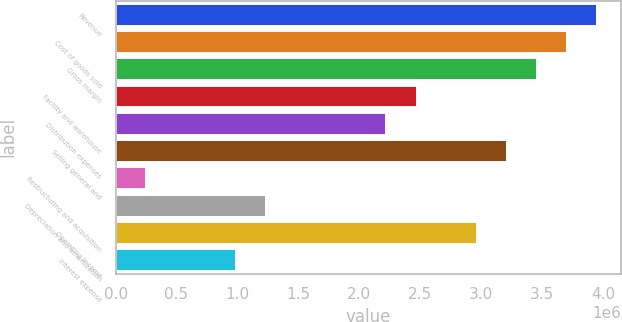Convert chart. <chart><loc_0><loc_0><loc_500><loc_500><bar_chart><fcel>Revenue<fcel>Cost of goods sold<fcel>Gross margin<fcel>Facility and warehouse<fcel>Distribution expenses<fcel>Selling general and<fcel>Restructuring and acquisition<fcel>Depreciation and amortization<fcel>Operating income<fcel>Interest expense<nl><fcel>3.95181e+06<fcel>3.70482e+06<fcel>3.45783e+06<fcel>2.46988e+06<fcel>2.22289e+06<fcel>3.21085e+06<fcel>246989<fcel>1.23494e+06<fcel>2.96386e+06<fcel>987953<nl></chart> 